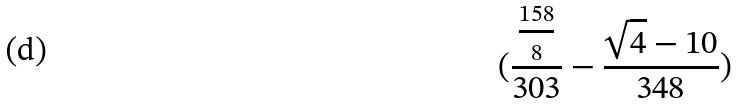<formula> <loc_0><loc_0><loc_500><loc_500>( \frac { \frac { 1 5 8 } { 8 } } { 3 0 3 } - \frac { \sqrt { 4 } - 1 0 } { 3 4 8 } )</formula> 